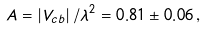<formula> <loc_0><loc_0><loc_500><loc_500>A = \left | V _ { c b } \right | / \lambda ^ { 2 } = 0 . 8 1 \pm 0 . 0 6 \, ,</formula> 